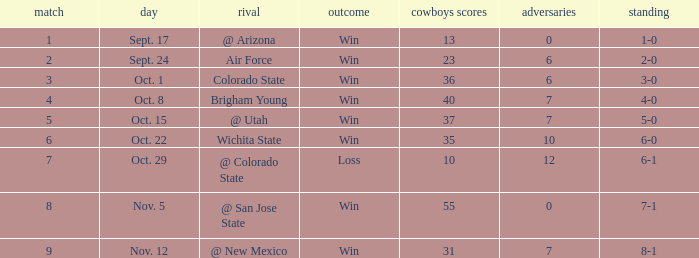When did the Cowboys score 13 points in 1966? Sept. 17. Could you help me parse every detail presented in this table? {'header': ['match', 'day', 'rival', 'outcome', 'cowboys scores', 'adversaries', 'standing'], 'rows': [['1', 'Sept. 17', '@ Arizona', 'Win', '13', '0', '1-0'], ['2', 'Sept. 24', 'Air Force', 'Win', '23', '6', '2-0'], ['3', 'Oct. 1', 'Colorado State', 'Win', '36', '6', '3-0'], ['4', 'Oct. 8', 'Brigham Young', 'Win', '40', '7', '4-0'], ['5', 'Oct. 15', '@ Utah', 'Win', '37', '7', '5-0'], ['6', 'Oct. 22', 'Wichita State', 'Win', '35', '10', '6-0'], ['7', 'Oct. 29', '@ Colorado State', 'Loss', '10', '12', '6-1'], ['8', 'Nov. 5', '@ San Jose State', 'Win', '55', '0', '7-1'], ['9', 'Nov. 12', '@ New Mexico', 'Win', '31', '7', '8-1']]} 